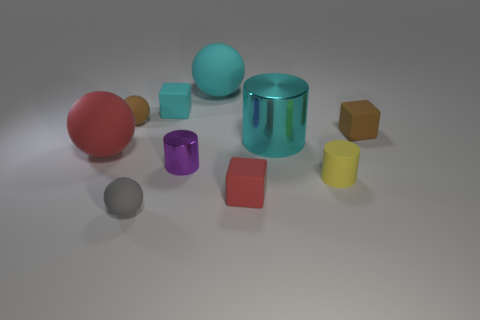Does the yellow thing have the same material as the purple cylinder?
Your answer should be very brief. No. What is the material of the large sphere in front of the brown object that is left of the red cube?
Ensure brevity in your answer.  Rubber. What material is the cyan object that is the same shape as the tiny red object?
Your answer should be very brief. Rubber. Are there any matte spheres that are right of the rubber block that is behind the small matte sphere left of the gray sphere?
Make the answer very short. Yes. What number of other objects are there of the same color as the matte cylinder?
Your response must be concise. 0. How many rubber balls are behind the rubber cylinder and in front of the large cyan matte sphere?
Offer a terse response. 2. What shape is the large shiny thing?
Offer a very short reply. Cylinder. What number of other things are there of the same material as the big red sphere
Make the answer very short. 7. There is a big thing to the left of the large rubber sphere that is behind the big rubber thing to the left of the small purple object; what color is it?
Provide a short and direct response. Red. What is the material of the purple cylinder that is the same size as the brown matte sphere?
Ensure brevity in your answer.  Metal. 